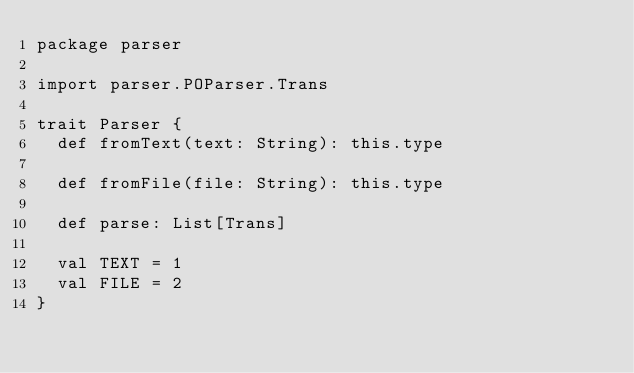<code> <loc_0><loc_0><loc_500><loc_500><_Scala_>package parser

import parser.POParser.Trans

trait Parser {
  def fromText(text: String): this.type

  def fromFile(file: String): this.type

  def parse: List[Trans]

  val TEXT = 1
  val FILE = 2
}
</code> 